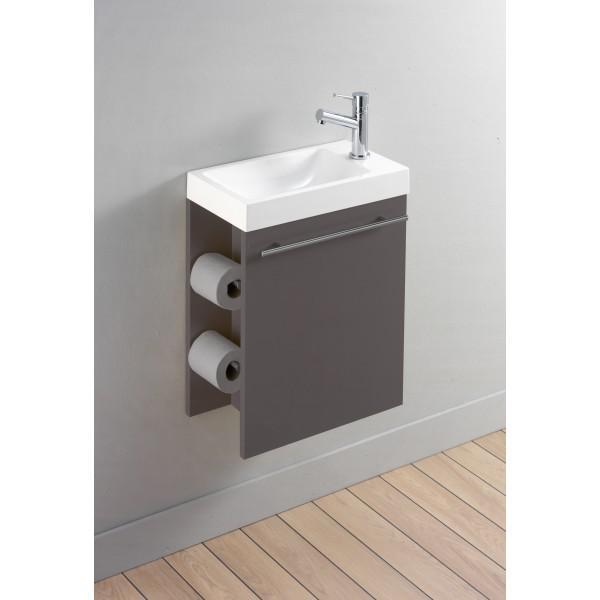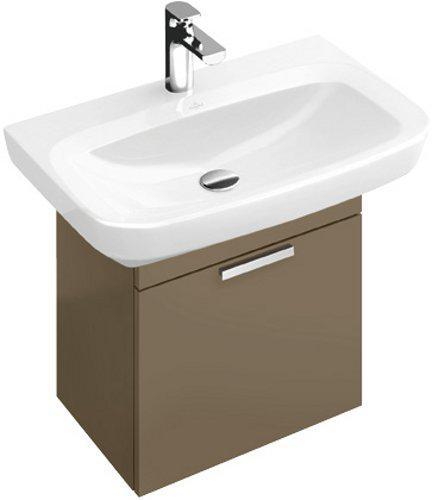The first image is the image on the left, the second image is the image on the right. For the images shown, is this caption "The door on one of the cabinets is open." true? Answer yes or no. No. The first image is the image on the left, the second image is the image on the right. Given the left and right images, does the statement "The left image features a white rectangular wall-mounted sink with its spout on the right side and a box shape underneath that does not extend to the floor." hold true? Answer yes or no. Yes. 